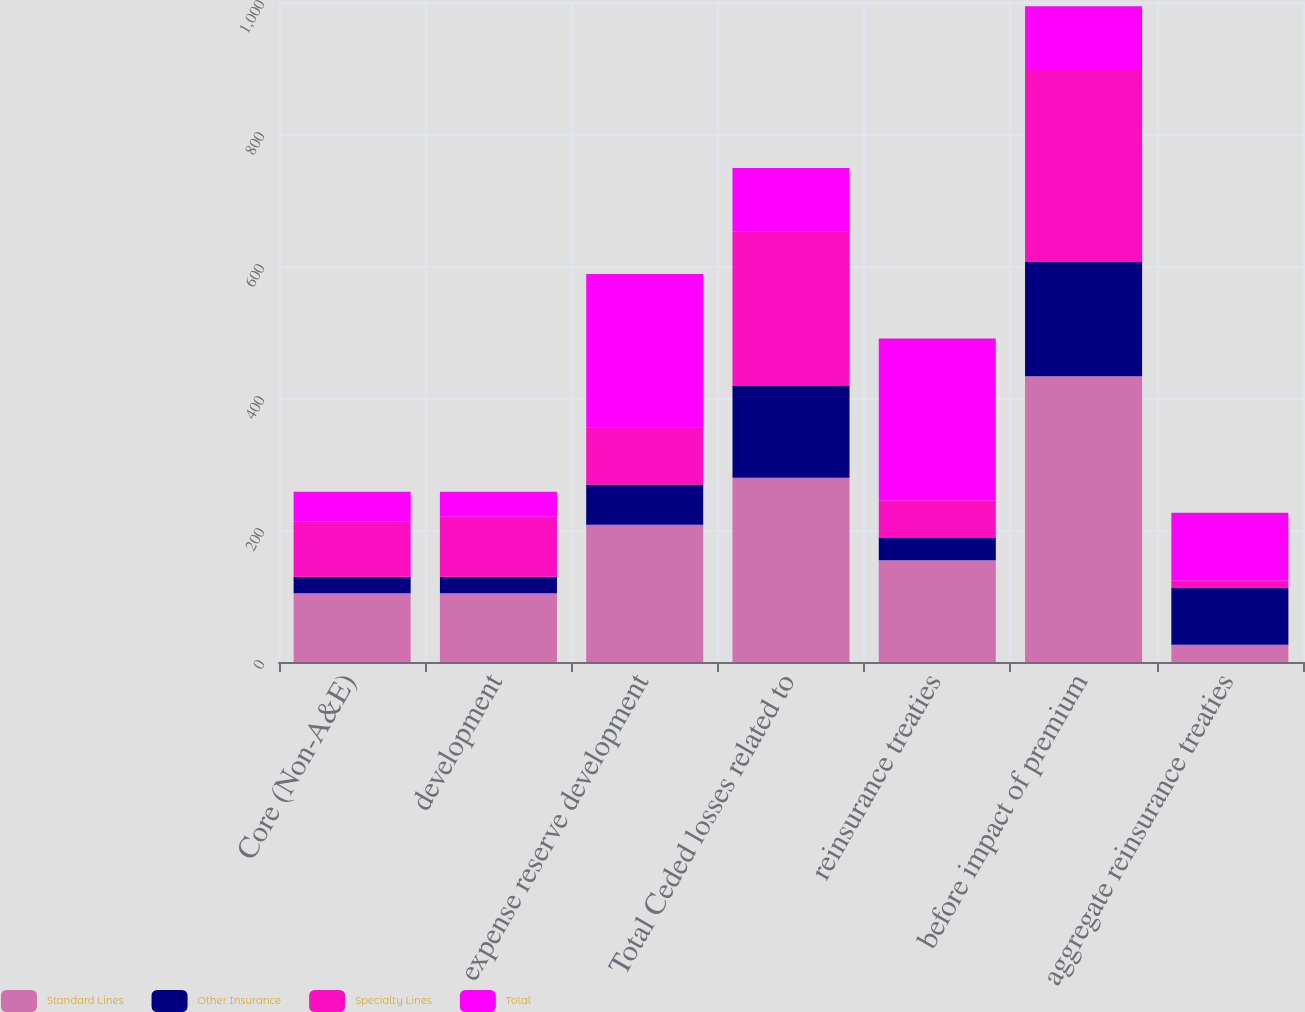Convert chart. <chart><loc_0><loc_0><loc_500><loc_500><stacked_bar_chart><ecel><fcel>Core (Non-A&E)<fcel>development<fcel>expense reserve development<fcel>Total Ceded losses related to<fcel>reinsurance treaties<fcel>before impact of premium<fcel>aggregate reinsurance treaties<nl><fcel>Standard Lines<fcel>104<fcel>104<fcel>208<fcel>279<fcel>154<fcel>433<fcel>26<nl><fcel>Other Insurance<fcel>25<fcel>25<fcel>61<fcel>139<fcel>34<fcel>173<fcel>87<nl><fcel>Specialty Lines<fcel>84<fcel>91<fcel>86<fcel>234<fcel>57<fcel>291<fcel>11<nl><fcel>Total<fcel>45<fcel>38<fcel>233<fcel>96.5<fcel>245<fcel>96.5<fcel>102<nl></chart> 